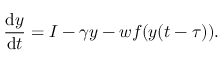<formula> <loc_0><loc_0><loc_500><loc_500>\frac { d y } { d t } = I - \gamma y - w f ( y ( t - \tau ) ) .</formula> 